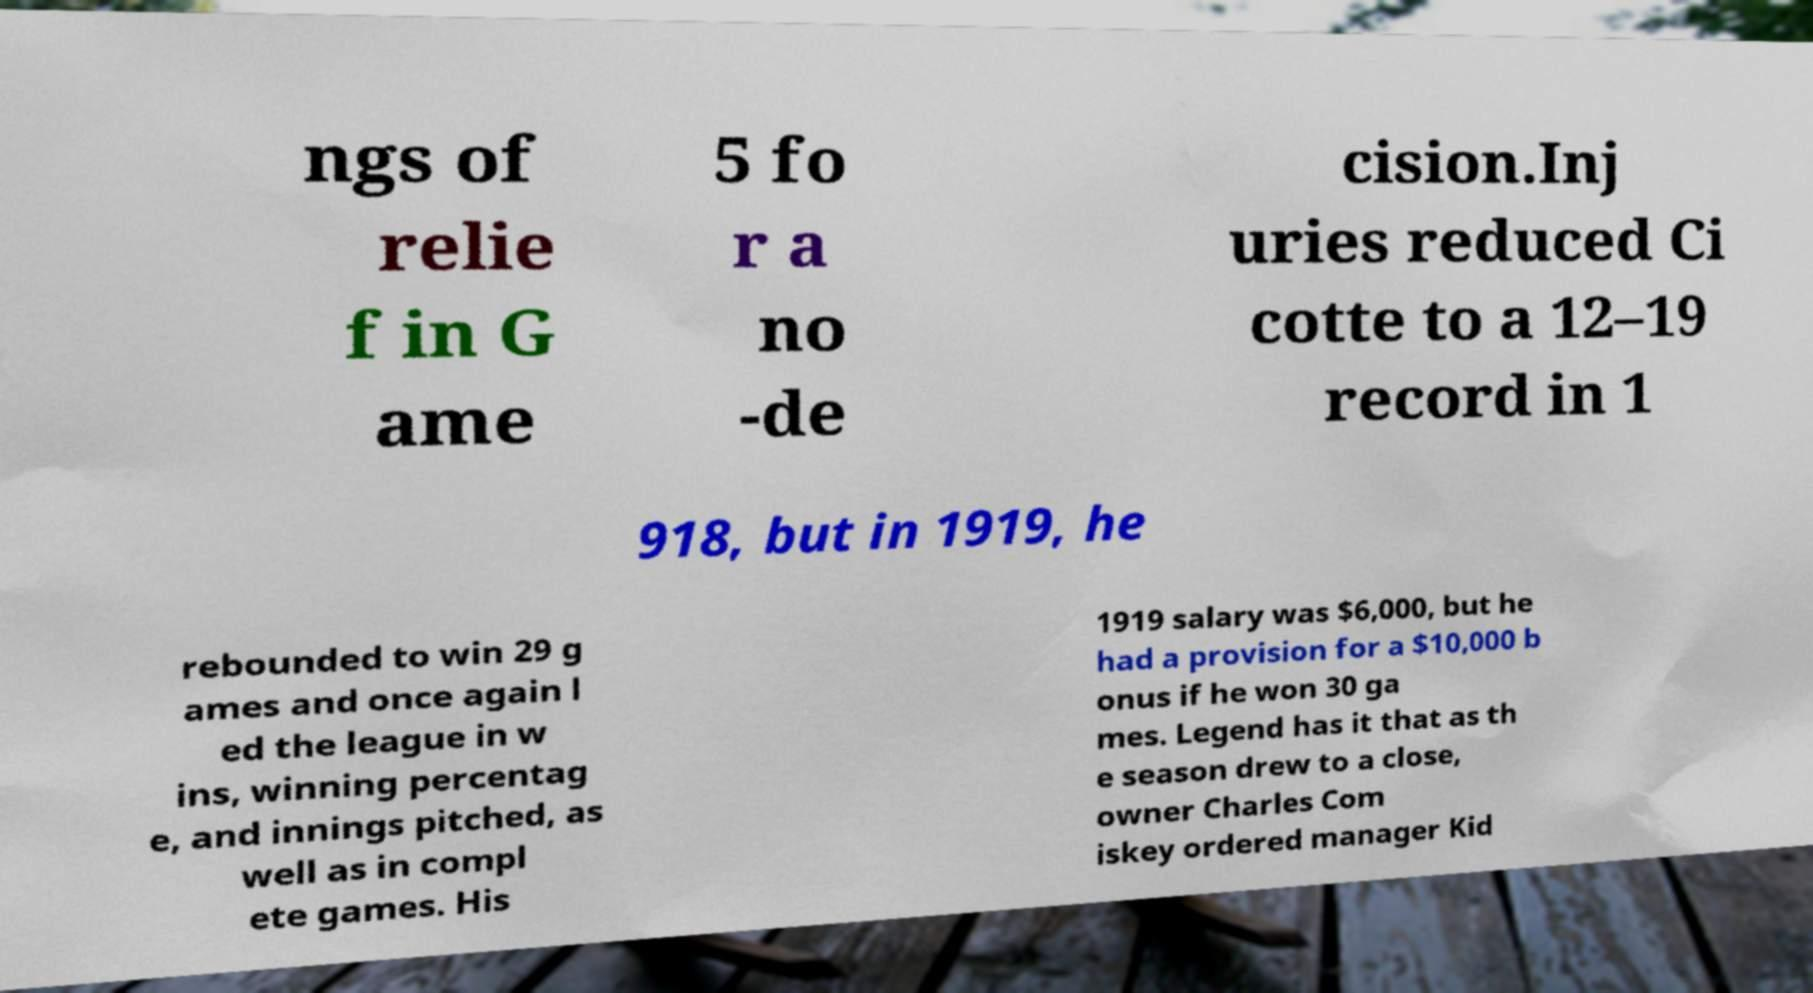Can you accurately transcribe the text from the provided image for me? ngs of relie f in G ame 5 fo r a no -de cision.Inj uries reduced Ci cotte to a 12–19 record in 1 918, but in 1919, he rebounded to win 29 g ames and once again l ed the league in w ins, winning percentag e, and innings pitched, as well as in compl ete games. His 1919 salary was $6,000, but he had a provision for a $10,000 b onus if he won 30 ga mes. Legend has it that as th e season drew to a close, owner Charles Com iskey ordered manager Kid 